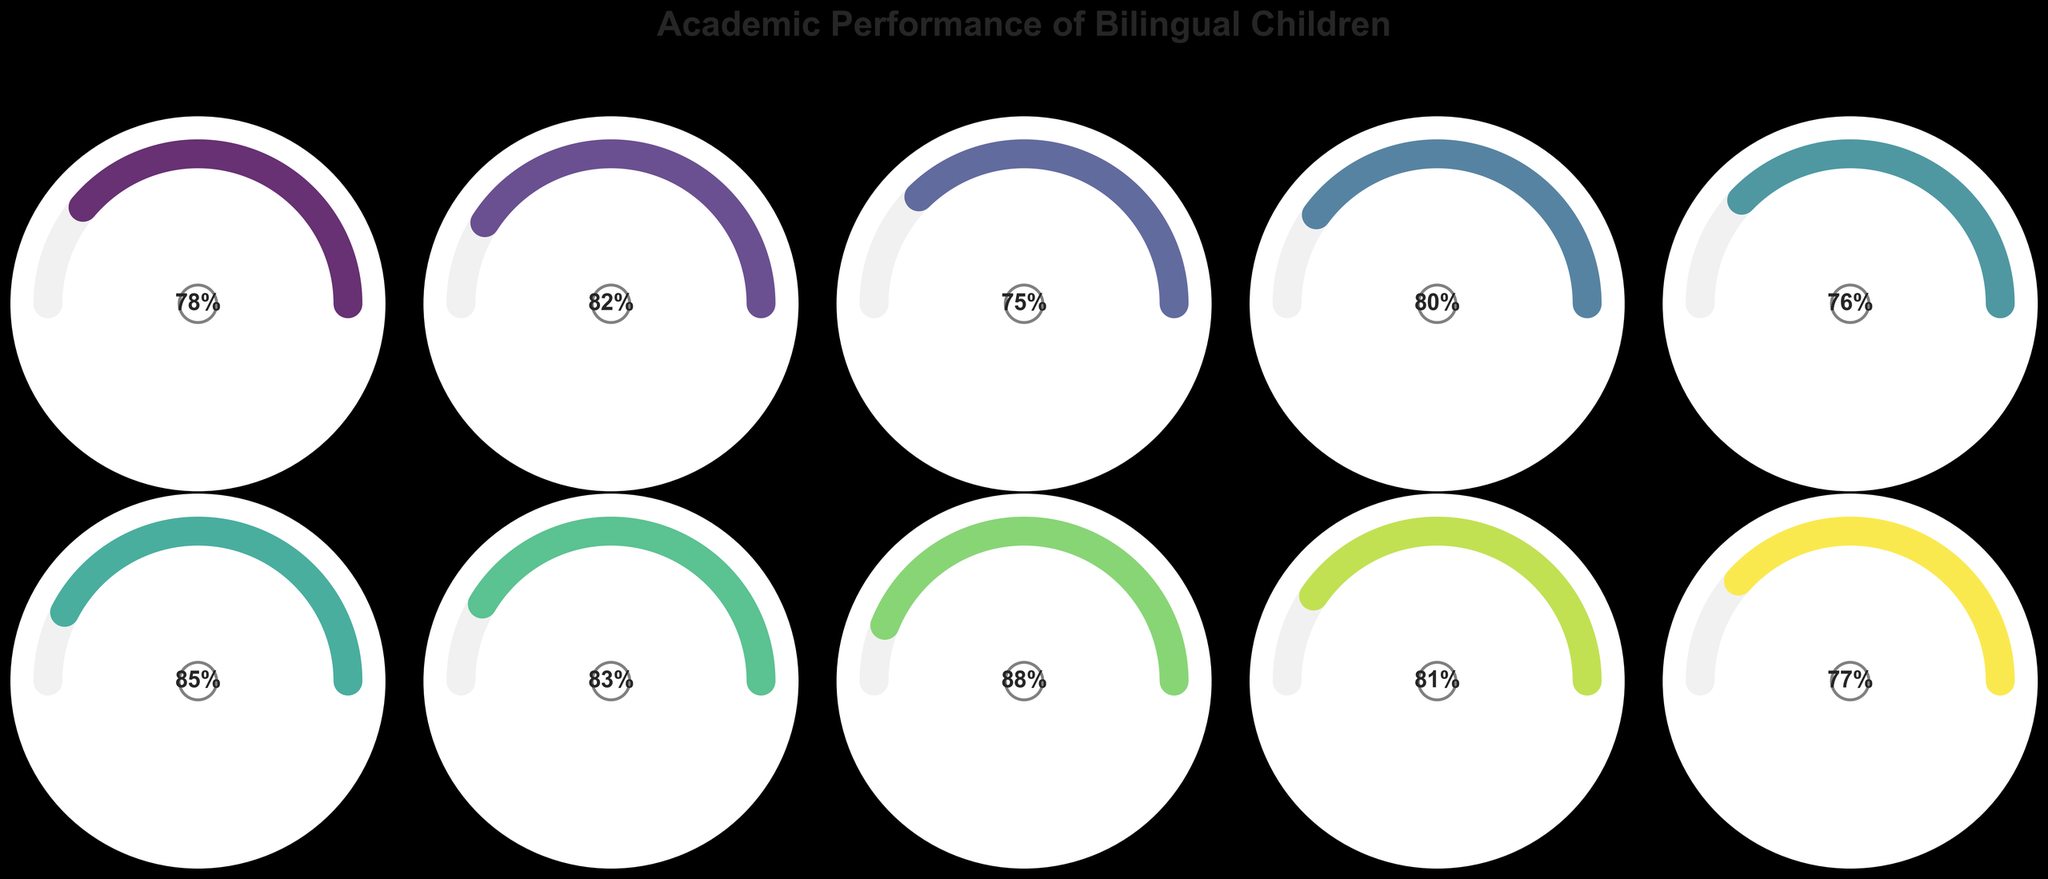What is the percentile ranking for Vocabulary? The segment for Vocabulary has an arc that extends to 88 on the percentile range. The percentage text inside the gauge also confirms this.
Answer: 88 Which subject has the lowest percentile ranking? By comparing the final positions of the arcs, Social Studies has the lowest percentile at 77, as indicated by the position and the text inside the gauge.
Answer: Social Studies How many subjects have a percentile ranking of 80 or above? From the gauge charts, the subjects with percentiles of 80 or above are Reading Comprehension, Mathematics, Critical Thinking, Problem Solving, Vocabulary, and Language Arts. Counting these gives 6 subjects.
Answer: 6 What is the average percentile ranking for Reading Comprehension, Writing Skills, and Mathematics? Reading Comprehension is 82, Writing Skills is 75, and Mathematics is 80. The sum is (82 + 75 + 80) = 237. Dividing by 3 gives an average of 79.
Answer: 79 Which subject has the highest percentile ranking, and how much higher is it compared to Science? Vocabulary has the highest percentile ranking at 88. Science is at 76. The difference between 88 and 76 is 12.
Answer: Vocabulary, 12 Is the percentile rank in Language Arts higher than in Reading Comprehension? Comparing the percentile marks, Language Arts is at 81, while Reading Comprehension is at 82. Therefore, Language Arts is not higher.
Answer: No Which two subjects have a percentile ranking closest to each other? From the gauge charts, Overall Academic Performance (78) and Writing Skills (75) are the closest together, with a difference of 3.
Answer: Overall Academic Performance and Writing Skills What is the range of the percentile rankings in the dataset? The highest percentile is Vocabulary at 88, and the lowest is Social Studies at 77. The range is calculated by subtracting the lowest from the highest: 88 - 77 = 11.
Answer: 11 How does the percentile rank of Critical Thinking compare to Problem Solving? The Critical Thinking gauge shows 85, while the Problem Solving gauge shows 83. Critical Thinking is higher by 2 percentiles.
Answer: Critical Thinking is 2 higher If we combine the percentile scores of Mathematics and Science, is the total greater than twice the percentile of Writing Skills? Mathematics (80) + Science (76) = 156. Writing Skills is 75, so twice that would be 75 * 2 = 150. Yes, 156 is greater than 150.
Answer: Yes 